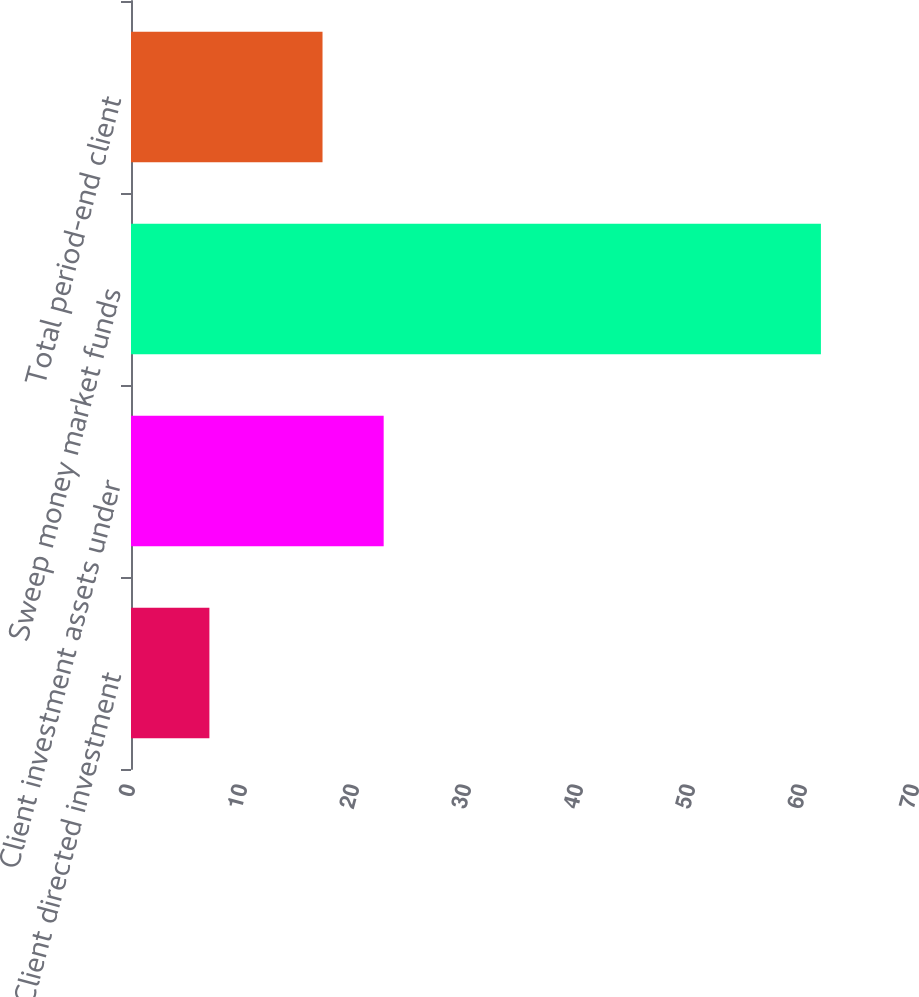Convert chart to OTSL. <chart><loc_0><loc_0><loc_500><loc_500><bar_chart><fcel>Client directed investment<fcel>Client investment assets under<fcel>Sweep money market funds<fcel>Total period-end client<nl><fcel>7<fcel>22.56<fcel>61.6<fcel>17.1<nl></chart> 